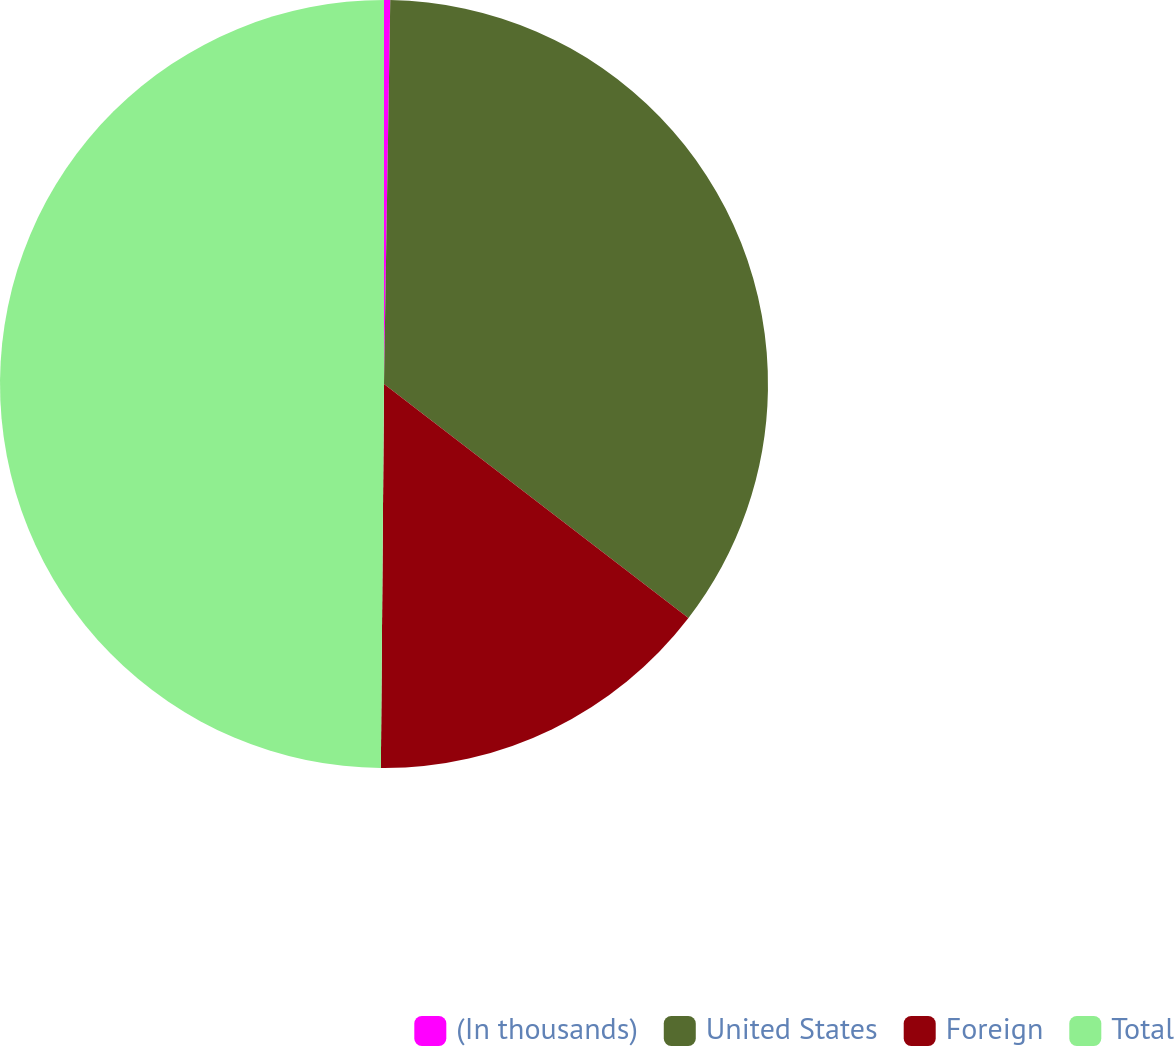Convert chart to OTSL. <chart><loc_0><loc_0><loc_500><loc_500><pie_chart><fcel>(In thousands)<fcel>United States<fcel>Foreign<fcel>Total<nl><fcel>0.26%<fcel>35.17%<fcel>14.7%<fcel>49.87%<nl></chart> 